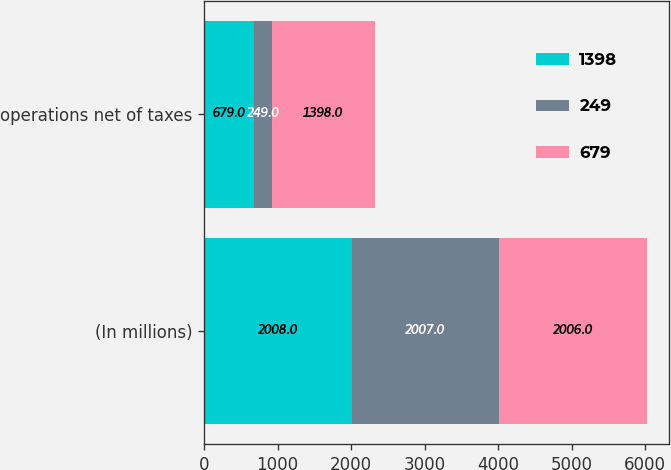Convert chart to OTSL. <chart><loc_0><loc_0><loc_500><loc_500><stacked_bar_chart><ecel><fcel>(In millions)<fcel>operations net of taxes<nl><fcel>1398<fcel>2008<fcel>679<nl><fcel>249<fcel>2007<fcel>249<nl><fcel>679<fcel>2006<fcel>1398<nl></chart> 